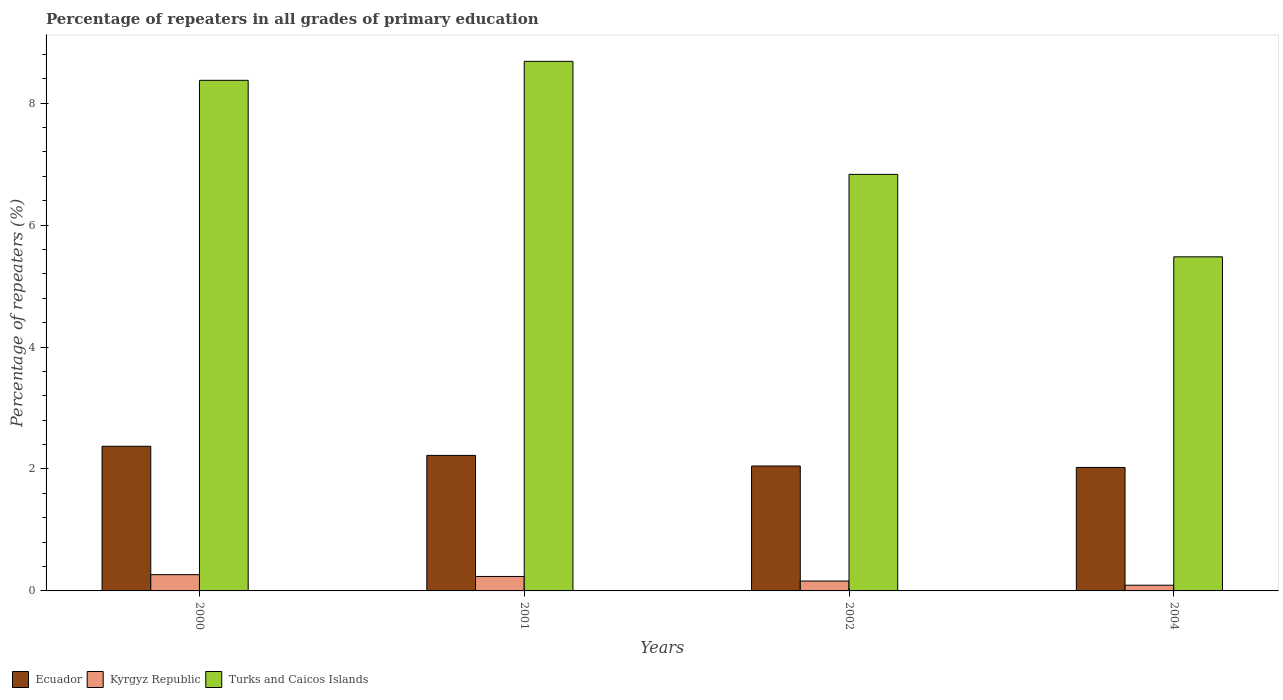Are the number of bars on each tick of the X-axis equal?
Offer a very short reply. Yes. How many bars are there on the 1st tick from the right?
Offer a terse response. 3. What is the percentage of repeaters in Kyrgyz Republic in 2004?
Your response must be concise. 0.09. Across all years, what is the maximum percentage of repeaters in Turks and Caicos Islands?
Keep it short and to the point. 8.69. Across all years, what is the minimum percentage of repeaters in Ecuador?
Your answer should be very brief. 2.03. In which year was the percentage of repeaters in Ecuador minimum?
Your response must be concise. 2004. What is the total percentage of repeaters in Kyrgyz Republic in the graph?
Offer a very short reply. 0.76. What is the difference between the percentage of repeaters in Ecuador in 2001 and that in 2002?
Offer a terse response. 0.17. What is the difference between the percentage of repeaters in Turks and Caicos Islands in 2000 and the percentage of repeaters in Ecuador in 2004?
Ensure brevity in your answer.  6.35. What is the average percentage of repeaters in Ecuador per year?
Offer a terse response. 2.17. In the year 2002, what is the difference between the percentage of repeaters in Turks and Caicos Islands and percentage of repeaters in Ecuador?
Provide a short and direct response. 4.78. What is the ratio of the percentage of repeaters in Ecuador in 2001 to that in 2004?
Your answer should be very brief. 1.1. Is the difference between the percentage of repeaters in Turks and Caicos Islands in 2000 and 2004 greater than the difference between the percentage of repeaters in Ecuador in 2000 and 2004?
Offer a terse response. Yes. What is the difference between the highest and the second highest percentage of repeaters in Kyrgyz Republic?
Offer a very short reply. 0.03. What is the difference between the highest and the lowest percentage of repeaters in Kyrgyz Republic?
Keep it short and to the point. 0.17. Is the sum of the percentage of repeaters in Kyrgyz Republic in 2001 and 2004 greater than the maximum percentage of repeaters in Ecuador across all years?
Give a very brief answer. No. What does the 3rd bar from the left in 2004 represents?
Provide a short and direct response. Turks and Caicos Islands. What does the 3rd bar from the right in 2002 represents?
Provide a short and direct response. Ecuador. How many bars are there?
Make the answer very short. 12. How many years are there in the graph?
Your answer should be very brief. 4. What is the difference between two consecutive major ticks on the Y-axis?
Your answer should be very brief. 2. Does the graph contain any zero values?
Your answer should be very brief. No. Does the graph contain grids?
Keep it short and to the point. No. Where does the legend appear in the graph?
Your answer should be very brief. Bottom left. What is the title of the graph?
Your answer should be compact. Percentage of repeaters in all grades of primary education. What is the label or title of the X-axis?
Keep it short and to the point. Years. What is the label or title of the Y-axis?
Your answer should be very brief. Percentage of repeaters (%). What is the Percentage of repeaters (%) of Ecuador in 2000?
Keep it short and to the point. 2.37. What is the Percentage of repeaters (%) in Kyrgyz Republic in 2000?
Make the answer very short. 0.27. What is the Percentage of repeaters (%) of Turks and Caicos Islands in 2000?
Ensure brevity in your answer.  8.37. What is the Percentage of repeaters (%) in Ecuador in 2001?
Your answer should be compact. 2.22. What is the Percentage of repeaters (%) in Kyrgyz Republic in 2001?
Your answer should be very brief. 0.24. What is the Percentage of repeaters (%) in Turks and Caicos Islands in 2001?
Ensure brevity in your answer.  8.69. What is the Percentage of repeaters (%) of Ecuador in 2002?
Your answer should be compact. 2.05. What is the Percentage of repeaters (%) in Kyrgyz Republic in 2002?
Your response must be concise. 0.16. What is the Percentage of repeaters (%) in Turks and Caicos Islands in 2002?
Give a very brief answer. 6.83. What is the Percentage of repeaters (%) of Ecuador in 2004?
Your response must be concise. 2.03. What is the Percentage of repeaters (%) of Kyrgyz Republic in 2004?
Offer a very short reply. 0.09. What is the Percentage of repeaters (%) of Turks and Caicos Islands in 2004?
Offer a very short reply. 5.48. Across all years, what is the maximum Percentage of repeaters (%) of Ecuador?
Offer a terse response. 2.37. Across all years, what is the maximum Percentage of repeaters (%) in Kyrgyz Republic?
Offer a terse response. 0.27. Across all years, what is the maximum Percentage of repeaters (%) of Turks and Caicos Islands?
Give a very brief answer. 8.69. Across all years, what is the minimum Percentage of repeaters (%) of Ecuador?
Keep it short and to the point. 2.03. Across all years, what is the minimum Percentage of repeaters (%) in Kyrgyz Republic?
Your answer should be compact. 0.09. Across all years, what is the minimum Percentage of repeaters (%) of Turks and Caicos Islands?
Provide a succinct answer. 5.48. What is the total Percentage of repeaters (%) in Ecuador in the graph?
Ensure brevity in your answer.  8.67. What is the total Percentage of repeaters (%) of Kyrgyz Republic in the graph?
Your response must be concise. 0.76. What is the total Percentage of repeaters (%) in Turks and Caicos Islands in the graph?
Your answer should be compact. 29.37. What is the difference between the Percentage of repeaters (%) of Ecuador in 2000 and that in 2001?
Your response must be concise. 0.15. What is the difference between the Percentage of repeaters (%) in Kyrgyz Republic in 2000 and that in 2001?
Make the answer very short. 0.03. What is the difference between the Percentage of repeaters (%) in Turks and Caicos Islands in 2000 and that in 2001?
Offer a very short reply. -0.31. What is the difference between the Percentage of repeaters (%) in Ecuador in 2000 and that in 2002?
Your answer should be compact. 0.32. What is the difference between the Percentage of repeaters (%) of Kyrgyz Republic in 2000 and that in 2002?
Provide a succinct answer. 0.1. What is the difference between the Percentage of repeaters (%) in Turks and Caicos Islands in 2000 and that in 2002?
Provide a succinct answer. 1.54. What is the difference between the Percentage of repeaters (%) of Ecuador in 2000 and that in 2004?
Offer a terse response. 0.35. What is the difference between the Percentage of repeaters (%) in Kyrgyz Republic in 2000 and that in 2004?
Offer a very short reply. 0.17. What is the difference between the Percentage of repeaters (%) in Turks and Caicos Islands in 2000 and that in 2004?
Provide a short and direct response. 2.9. What is the difference between the Percentage of repeaters (%) in Ecuador in 2001 and that in 2002?
Offer a very short reply. 0.17. What is the difference between the Percentage of repeaters (%) in Kyrgyz Republic in 2001 and that in 2002?
Make the answer very short. 0.07. What is the difference between the Percentage of repeaters (%) in Turks and Caicos Islands in 2001 and that in 2002?
Offer a very short reply. 1.85. What is the difference between the Percentage of repeaters (%) of Ecuador in 2001 and that in 2004?
Your response must be concise. 0.2. What is the difference between the Percentage of repeaters (%) in Kyrgyz Republic in 2001 and that in 2004?
Your answer should be very brief. 0.14. What is the difference between the Percentage of repeaters (%) in Turks and Caicos Islands in 2001 and that in 2004?
Provide a succinct answer. 3.21. What is the difference between the Percentage of repeaters (%) of Ecuador in 2002 and that in 2004?
Give a very brief answer. 0.02. What is the difference between the Percentage of repeaters (%) in Kyrgyz Republic in 2002 and that in 2004?
Make the answer very short. 0.07. What is the difference between the Percentage of repeaters (%) in Turks and Caicos Islands in 2002 and that in 2004?
Provide a short and direct response. 1.35. What is the difference between the Percentage of repeaters (%) in Ecuador in 2000 and the Percentage of repeaters (%) in Kyrgyz Republic in 2001?
Ensure brevity in your answer.  2.14. What is the difference between the Percentage of repeaters (%) of Ecuador in 2000 and the Percentage of repeaters (%) of Turks and Caicos Islands in 2001?
Your response must be concise. -6.31. What is the difference between the Percentage of repeaters (%) of Kyrgyz Republic in 2000 and the Percentage of repeaters (%) of Turks and Caicos Islands in 2001?
Your answer should be compact. -8.42. What is the difference between the Percentage of repeaters (%) in Ecuador in 2000 and the Percentage of repeaters (%) in Kyrgyz Republic in 2002?
Provide a short and direct response. 2.21. What is the difference between the Percentage of repeaters (%) in Ecuador in 2000 and the Percentage of repeaters (%) in Turks and Caicos Islands in 2002?
Your answer should be very brief. -4.46. What is the difference between the Percentage of repeaters (%) of Kyrgyz Republic in 2000 and the Percentage of repeaters (%) of Turks and Caicos Islands in 2002?
Offer a terse response. -6.57. What is the difference between the Percentage of repeaters (%) in Ecuador in 2000 and the Percentage of repeaters (%) in Kyrgyz Republic in 2004?
Your answer should be very brief. 2.28. What is the difference between the Percentage of repeaters (%) in Ecuador in 2000 and the Percentage of repeaters (%) in Turks and Caicos Islands in 2004?
Give a very brief answer. -3.11. What is the difference between the Percentage of repeaters (%) of Kyrgyz Republic in 2000 and the Percentage of repeaters (%) of Turks and Caicos Islands in 2004?
Make the answer very short. -5.21. What is the difference between the Percentage of repeaters (%) in Ecuador in 2001 and the Percentage of repeaters (%) in Kyrgyz Republic in 2002?
Give a very brief answer. 2.06. What is the difference between the Percentage of repeaters (%) of Ecuador in 2001 and the Percentage of repeaters (%) of Turks and Caicos Islands in 2002?
Make the answer very short. -4.61. What is the difference between the Percentage of repeaters (%) in Kyrgyz Republic in 2001 and the Percentage of repeaters (%) in Turks and Caicos Islands in 2002?
Provide a succinct answer. -6.59. What is the difference between the Percentage of repeaters (%) of Ecuador in 2001 and the Percentage of repeaters (%) of Kyrgyz Republic in 2004?
Offer a very short reply. 2.13. What is the difference between the Percentage of repeaters (%) in Ecuador in 2001 and the Percentage of repeaters (%) in Turks and Caicos Islands in 2004?
Give a very brief answer. -3.26. What is the difference between the Percentage of repeaters (%) in Kyrgyz Republic in 2001 and the Percentage of repeaters (%) in Turks and Caicos Islands in 2004?
Your response must be concise. -5.24. What is the difference between the Percentage of repeaters (%) in Ecuador in 2002 and the Percentage of repeaters (%) in Kyrgyz Republic in 2004?
Your answer should be compact. 1.96. What is the difference between the Percentage of repeaters (%) of Ecuador in 2002 and the Percentage of repeaters (%) of Turks and Caicos Islands in 2004?
Provide a succinct answer. -3.43. What is the difference between the Percentage of repeaters (%) in Kyrgyz Republic in 2002 and the Percentage of repeaters (%) in Turks and Caicos Islands in 2004?
Your answer should be very brief. -5.32. What is the average Percentage of repeaters (%) in Ecuador per year?
Offer a very short reply. 2.17. What is the average Percentage of repeaters (%) in Kyrgyz Republic per year?
Ensure brevity in your answer.  0.19. What is the average Percentage of repeaters (%) of Turks and Caicos Islands per year?
Your answer should be compact. 7.34. In the year 2000, what is the difference between the Percentage of repeaters (%) of Ecuador and Percentage of repeaters (%) of Kyrgyz Republic?
Offer a terse response. 2.11. In the year 2000, what is the difference between the Percentage of repeaters (%) of Ecuador and Percentage of repeaters (%) of Turks and Caicos Islands?
Your answer should be very brief. -6. In the year 2000, what is the difference between the Percentage of repeaters (%) of Kyrgyz Republic and Percentage of repeaters (%) of Turks and Caicos Islands?
Ensure brevity in your answer.  -8.11. In the year 2001, what is the difference between the Percentage of repeaters (%) in Ecuador and Percentage of repeaters (%) in Kyrgyz Republic?
Keep it short and to the point. 1.99. In the year 2001, what is the difference between the Percentage of repeaters (%) in Ecuador and Percentage of repeaters (%) in Turks and Caicos Islands?
Provide a succinct answer. -6.46. In the year 2001, what is the difference between the Percentage of repeaters (%) of Kyrgyz Republic and Percentage of repeaters (%) of Turks and Caicos Islands?
Make the answer very short. -8.45. In the year 2002, what is the difference between the Percentage of repeaters (%) of Ecuador and Percentage of repeaters (%) of Kyrgyz Republic?
Provide a succinct answer. 1.89. In the year 2002, what is the difference between the Percentage of repeaters (%) in Ecuador and Percentage of repeaters (%) in Turks and Caicos Islands?
Offer a very short reply. -4.78. In the year 2002, what is the difference between the Percentage of repeaters (%) of Kyrgyz Republic and Percentage of repeaters (%) of Turks and Caicos Islands?
Offer a very short reply. -6.67. In the year 2004, what is the difference between the Percentage of repeaters (%) in Ecuador and Percentage of repeaters (%) in Kyrgyz Republic?
Offer a terse response. 1.93. In the year 2004, what is the difference between the Percentage of repeaters (%) in Ecuador and Percentage of repeaters (%) in Turks and Caicos Islands?
Make the answer very short. -3.45. In the year 2004, what is the difference between the Percentage of repeaters (%) of Kyrgyz Republic and Percentage of repeaters (%) of Turks and Caicos Islands?
Ensure brevity in your answer.  -5.39. What is the ratio of the Percentage of repeaters (%) of Ecuador in 2000 to that in 2001?
Provide a succinct answer. 1.07. What is the ratio of the Percentage of repeaters (%) of Kyrgyz Republic in 2000 to that in 2001?
Provide a short and direct response. 1.12. What is the ratio of the Percentage of repeaters (%) of Turks and Caicos Islands in 2000 to that in 2001?
Keep it short and to the point. 0.96. What is the ratio of the Percentage of repeaters (%) in Ecuador in 2000 to that in 2002?
Give a very brief answer. 1.16. What is the ratio of the Percentage of repeaters (%) of Kyrgyz Republic in 2000 to that in 2002?
Your response must be concise. 1.64. What is the ratio of the Percentage of repeaters (%) in Turks and Caicos Islands in 2000 to that in 2002?
Ensure brevity in your answer.  1.23. What is the ratio of the Percentage of repeaters (%) in Ecuador in 2000 to that in 2004?
Offer a terse response. 1.17. What is the ratio of the Percentage of repeaters (%) in Kyrgyz Republic in 2000 to that in 2004?
Give a very brief answer. 2.85. What is the ratio of the Percentage of repeaters (%) in Turks and Caicos Islands in 2000 to that in 2004?
Offer a terse response. 1.53. What is the ratio of the Percentage of repeaters (%) of Ecuador in 2001 to that in 2002?
Your response must be concise. 1.08. What is the ratio of the Percentage of repeaters (%) in Kyrgyz Republic in 2001 to that in 2002?
Offer a very short reply. 1.46. What is the ratio of the Percentage of repeaters (%) of Turks and Caicos Islands in 2001 to that in 2002?
Make the answer very short. 1.27. What is the ratio of the Percentage of repeaters (%) in Ecuador in 2001 to that in 2004?
Ensure brevity in your answer.  1.1. What is the ratio of the Percentage of repeaters (%) of Kyrgyz Republic in 2001 to that in 2004?
Make the answer very short. 2.53. What is the ratio of the Percentage of repeaters (%) in Turks and Caicos Islands in 2001 to that in 2004?
Your answer should be compact. 1.59. What is the ratio of the Percentage of repeaters (%) in Ecuador in 2002 to that in 2004?
Keep it short and to the point. 1.01. What is the ratio of the Percentage of repeaters (%) of Kyrgyz Republic in 2002 to that in 2004?
Your answer should be very brief. 1.73. What is the ratio of the Percentage of repeaters (%) of Turks and Caicos Islands in 2002 to that in 2004?
Offer a very short reply. 1.25. What is the difference between the highest and the second highest Percentage of repeaters (%) in Ecuador?
Provide a succinct answer. 0.15. What is the difference between the highest and the second highest Percentage of repeaters (%) of Kyrgyz Republic?
Your response must be concise. 0.03. What is the difference between the highest and the second highest Percentage of repeaters (%) in Turks and Caicos Islands?
Provide a short and direct response. 0.31. What is the difference between the highest and the lowest Percentage of repeaters (%) of Ecuador?
Your answer should be compact. 0.35. What is the difference between the highest and the lowest Percentage of repeaters (%) in Kyrgyz Republic?
Offer a terse response. 0.17. What is the difference between the highest and the lowest Percentage of repeaters (%) of Turks and Caicos Islands?
Offer a very short reply. 3.21. 